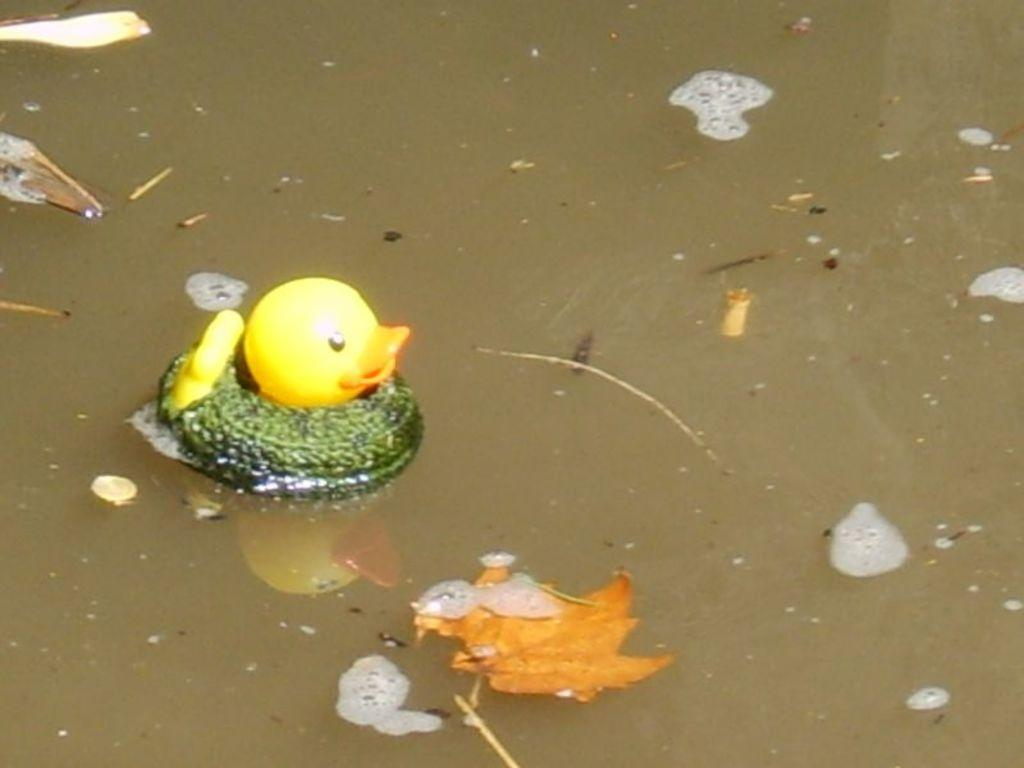What type of animal is in the image? There is a small duckling in the image. Where is the duckling located? The duckling is floating in the water. What else can be seen in the image? There are there any other elements? What type of experience can be heard in the image? There is no sound or experience present in the image, as it is a still image of a duckling floating in the water. 